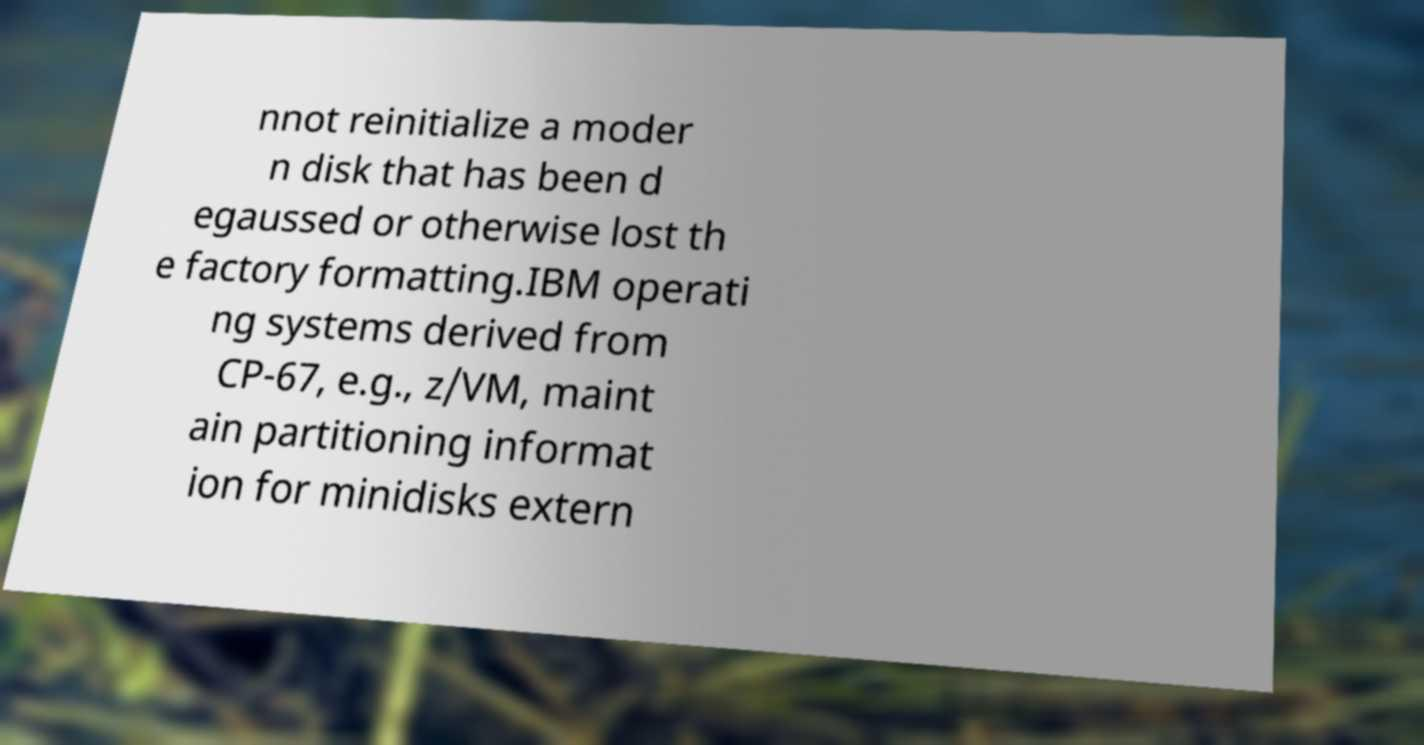Could you assist in decoding the text presented in this image and type it out clearly? nnot reinitialize a moder n disk that has been d egaussed or otherwise lost th e factory formatting.IBM operati ng systems derived from CP-67, e.g., z/VM, maint ain partitioning informat ion for minidisks extern 